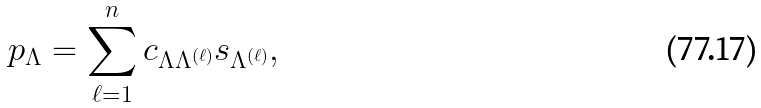Convert formula to latex. <formula><loc_0><loc_0><loc_500><loc_500>p _ { \Lambda } = \sum _ { \ell = 1 } ^ { n } c _ { \Lambda \Lambda ^ { ( \ell ) } } s _ { \Lambda ^ { ( \ell ) } } ,</formula> 